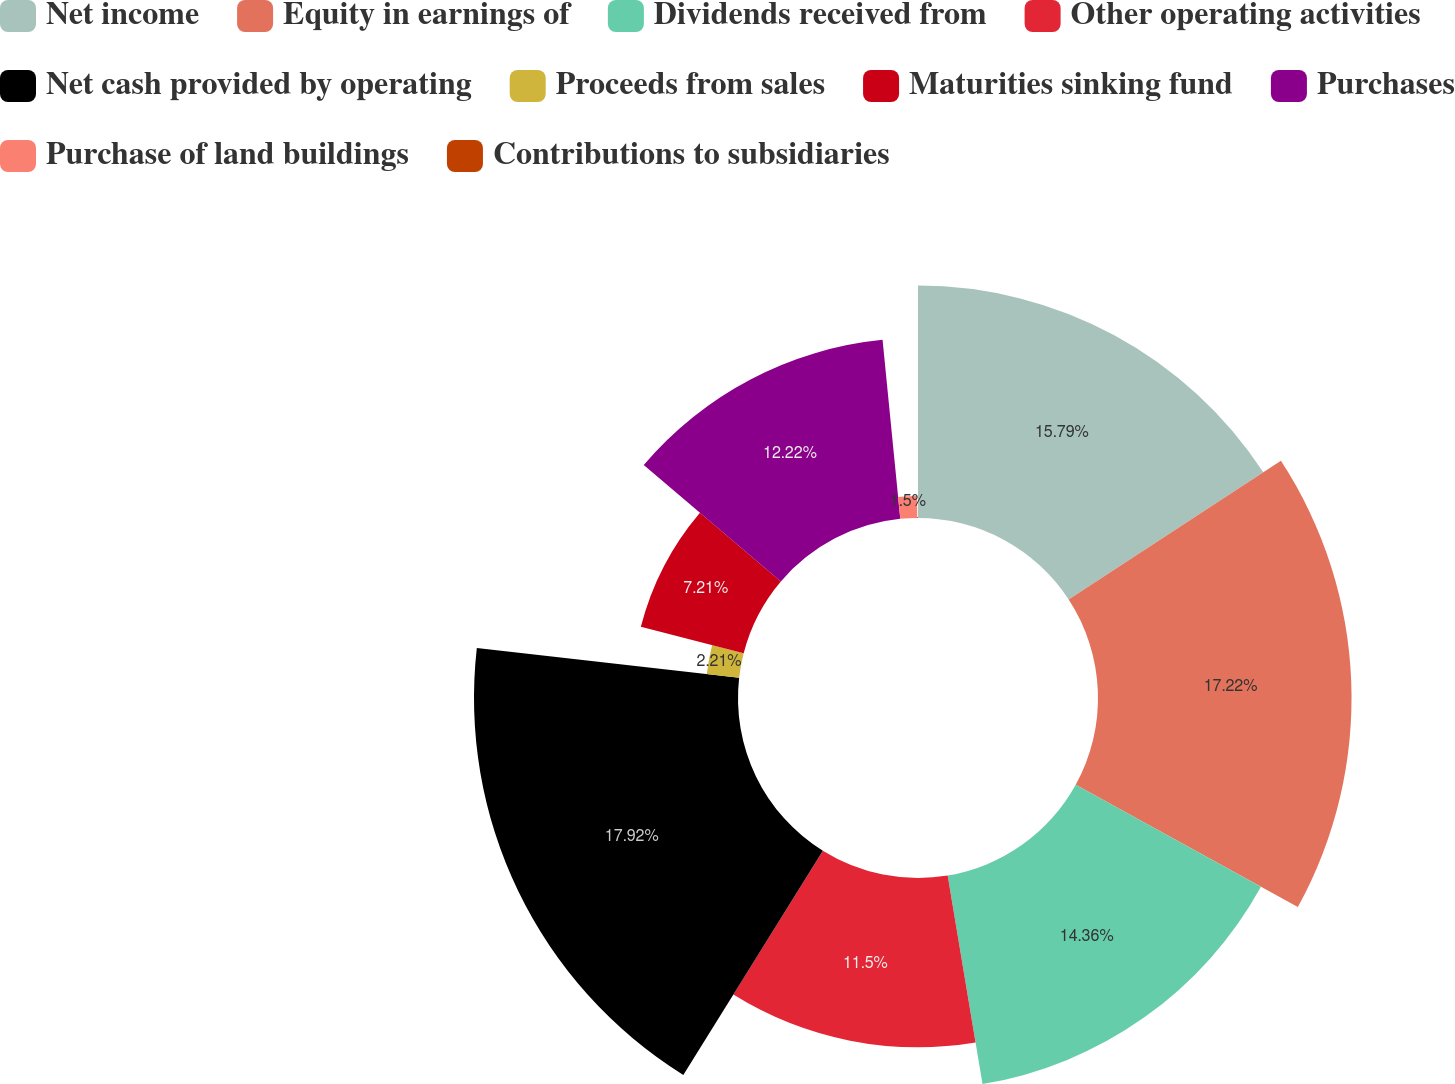Convert chart to OTSL. <chart><loc_0><loc_0><loc_500><loc_500><pie_chart><fcel>Net income<fcel>Equity in earnings of<fcel>Dividends received from<fcel>Other operating activities<fcel>Net cash provided by operating<fcel>Proceeds from sales<fcel>Maturities sinking fund<fcel>Purchases<fcel>Purchase of land buildings<fcel>Contributions to subsidiaries<nl><fcel>15.79%<fcel>17.22%<fcel>14.36%<fcel>11.5%<fcel>17.93%<fcel>2.21%<fcel>7.21%<fcel>12.22%<fcel>1.5%<fcel>0.07%<nl></chart> 